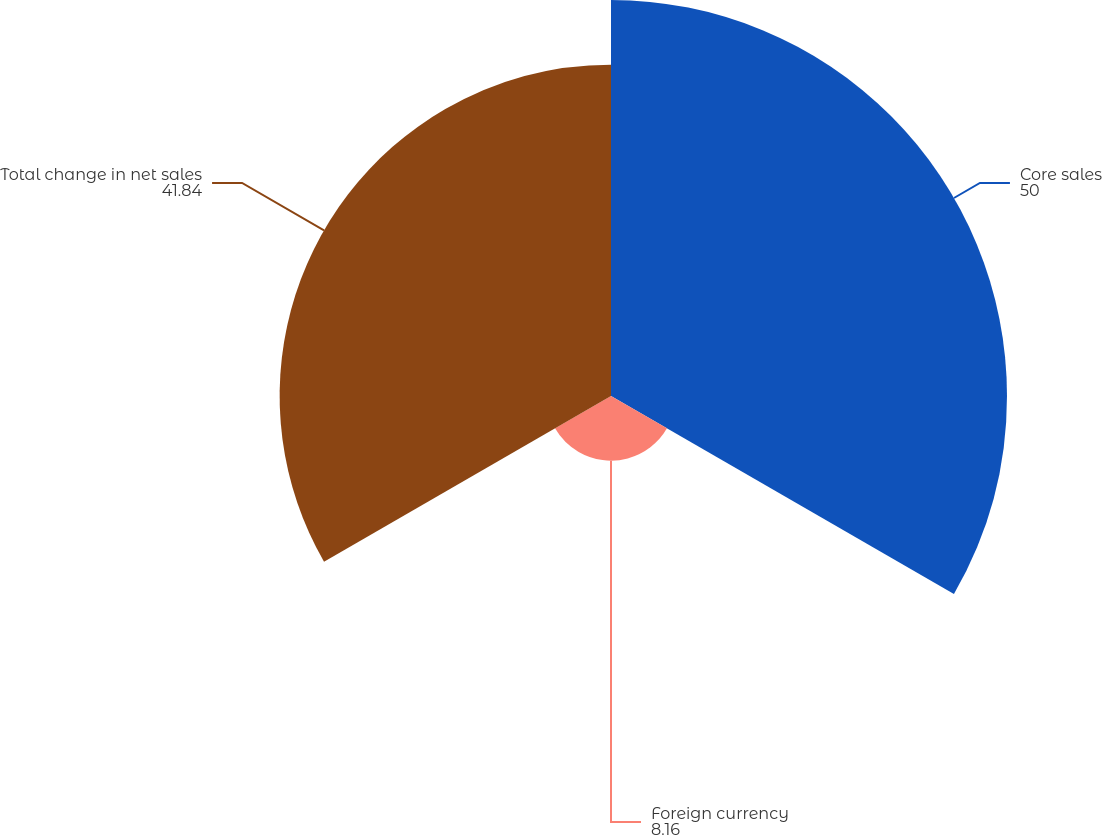Convert chart. <chart><loc_0><loc_0><loc_500><loc_500><pie_chart><fcel>Core sales<fcel>Foreign currency<fcel>Total change in net sales<nl><fcel>50.0%<fcel>8.16%<fcel>41.84%<nl></chart> 